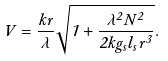<formula> <loc_0><loc_0><loc_500><loc_500>V = \frac { k r } { \lambda } \sqrt { 1 + \frac { \lambda ^ { 2 } N ^ { 2 } } { 2 k g _ { s } l _ { s } r ^ { 3 } } } .</formula> 